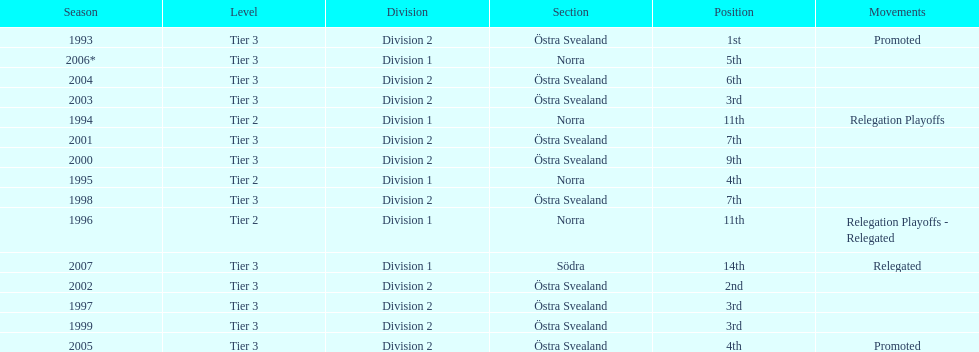How many times was norra mentioned as the section? 4. Could you help me parse every detail presented in this table? {'header': ['Season', 'Level', 'Division', 'Section', 'Position', 'Movements'], 'rows': [['1993', 'Tier 3', 'Division 2', 'Östra Svealand', '1st', 'Promoted'], ['2006*', 'Tier 3', 'Division 1', 'Norra', '5th', ''], ['2004', 'Tier 3', 'Division 2', 'Östra Svealand', '6th', ''], ['2003', 'Tier 3', 'Division 2', 'Östra Svealand', '3rd', ''], ['1994', 'Tier 2', 'Division 1', 'Norra', '11th', 'Relegation Playoffs'], ['2001', 'Tier 3', 'Division 2', 'Östra Svealand', '7th', ''], ['2000', 'Tier 3', 'Division 2', 'Östra Svealand', '9th', ''], ['1995', 'Tier 2', 'Division 1', 'Norra', '4th', ''], ['1998', 'Tier 3', 'Division 2', 'Östra Svealand', '7th', ''], ['1996', 'Tier 2', 'Division 1', 'Norra', '11th', 'Relegation Playoffs - Relegated'], ['2007', 'Tier 3', 'Division 1', 'Södra', '14th', 'Relegated'], ['2002', 'Tier 3', 'Division 2', 'Östra Svealand', '2nd', ''], ['1997', 'Tier 3', 'Division 2', 'Östra Svealand', '3rd', ''], ['1999', 'Tier 3', 'Division 2', 'Östra Svealand', '3rd', ''], ['2005', 'Tier 3', 'Division 2', 'Östra Svealand', '4th', 'Promoted']]} 